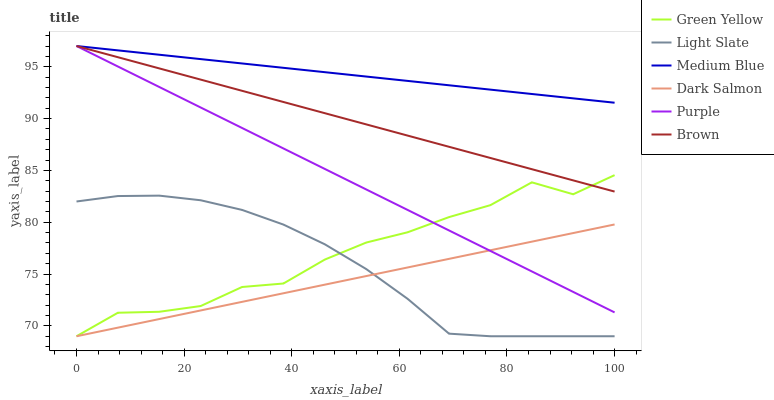Does Dark Salmon have the minimum area under the curve?
Answer yes or no. Yes. Does Medium Blue have the maximum area under the curve?
Answer yes or no. Yes. Does Light Slate have the minimum area under the curve?
Answer yes or no. No. Does Light Slate have the maximum area under the curve?
Answer yes or no. No. Is Medium Blue the smoothest?
Answer yes or no. Yes. Is Green Yellow the roughest?
Answer yes or no. Yes. Is Light Slate the smoothest?
Answer yes or no. No. Is Light Slate the roughest?
Answer yes or no. No. Does Light Slate have the lowest value?
Answer yes or no. Yes. Does Medium Blue have the lowest value?
Answer yes or no. No. Does Purple have the highest value?
Answer yes or no. Yes. Does Light Slate have the highest value?
Answer yes or no. No. Is Light Slate less than Purple?
Answer yes or no. Yes. Is Medium Blue greater than Dark Salmon?
Answer yes or no. Yes. Does Purple intersect Medium Blue?
Answer yes or no. Yes. Is Purple less than Medium Blue?
Answer yes or no. No. Is Purple greater than Medium Blue?
Answer yes or no. No. Does Light Slate intersect Purple?
Answer yes or no. No. 